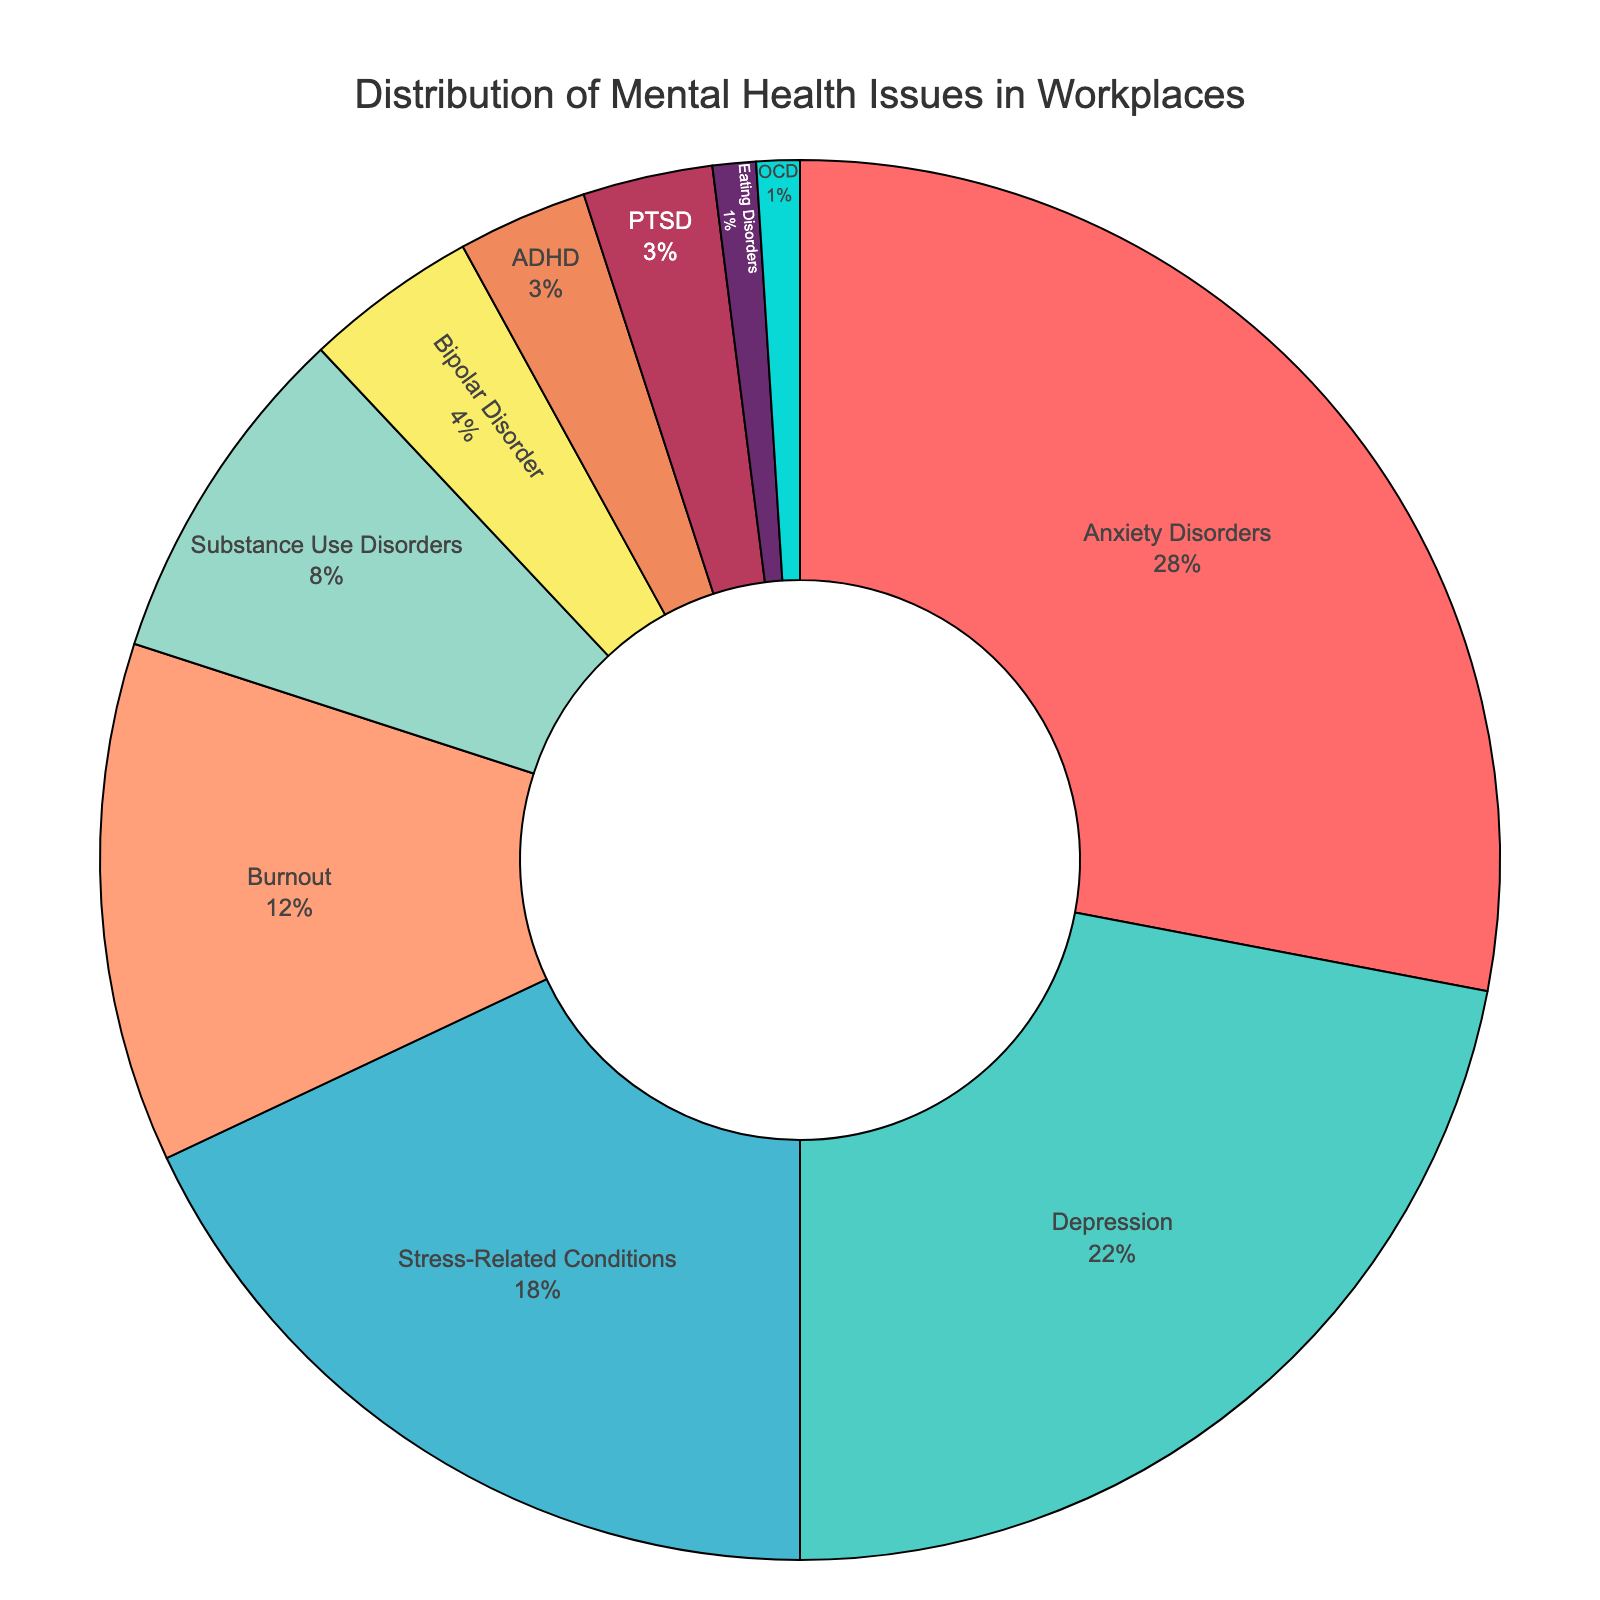what percentage of mental health issues reported are Anxiety Disorders? The percentage of Anxiety Disorders can be read directly from the figure. The label "Anxiety Disorders" shows that it constitutes 28% of the reported cases.
Answer: 28% Which mental health issue is reported the most in workplaces? The issue reported most prevalently in the workplace can be identified by the largest segment in the pie chart. The segment for "Anxiety Disorders" is the largest, confirming it as the most reported issue.
Answer: Anxiety Disorders Compare the combined percentage of Depression and Stress-Related Conditions to Anxiety Disorders. Are they greater, equal, or less? Adding the percentages for Depression (22%) and Stress-Related Conditions (18%) gives a combined percentage of 40%. Since 40% is greater than the 28% for Anxiety Disorders, the combination is greater.
Answer: Greater What color is used to represent Substance Use Disorders in the pie chart? The color corresponding to each segment can be observed visually. The segment for "Substance Use Disorders" is indicated by a blue shade.
Answer: Blue Is the presence of Burnout in reported mental health issues more than twice the percentage of ADHD? Checking the proportions, Burnout is 12% while ADHD is 3%. Since 12% is indeed more than twice of 3% (which would be 6%), the statement holds true.
Answer: Yes How does the combined percentage of OCD and Eating Disorders compare to PTSD? Summing the percentages of OCD (1%) and Eating Disorders (1%) gives 2%. Comparing this to PTSD, which is at 3%, the combined percentage is less.
Answer: Less What is the percentage difference between Depression and Substance Use Disorders? Depression accounts for 22% whereas Substance Use Disorders account for 8%. The difference is calculated as 22% - 8% = 14%.
Answer: 14% What mental health issue represented by a green color occupies a notable segment of the pie? By visually identifying the segments in green, we can see that it corresponds with Depression, which occupies a significant portion of the pie chart.
Answer: Depression Calculate the total percentage of the four least frequently reported mental health issues. The four least frequently reported issues are Eating Disorders (1%), OCD (1%), ADHD (3%), and PTSD (3%). Summing these gives 1% + 1% + 3% + 3% = 8%.
Answer: 8% Which mental health issues combined make up exactly half of the total reported issues? Adding the percentages of Anxiety Disorders (28%) and Depression (22%) results in 28% + 22% = 50%, which makes up exactly half of the total.
Answer: Anxiety Disorders and Depression 